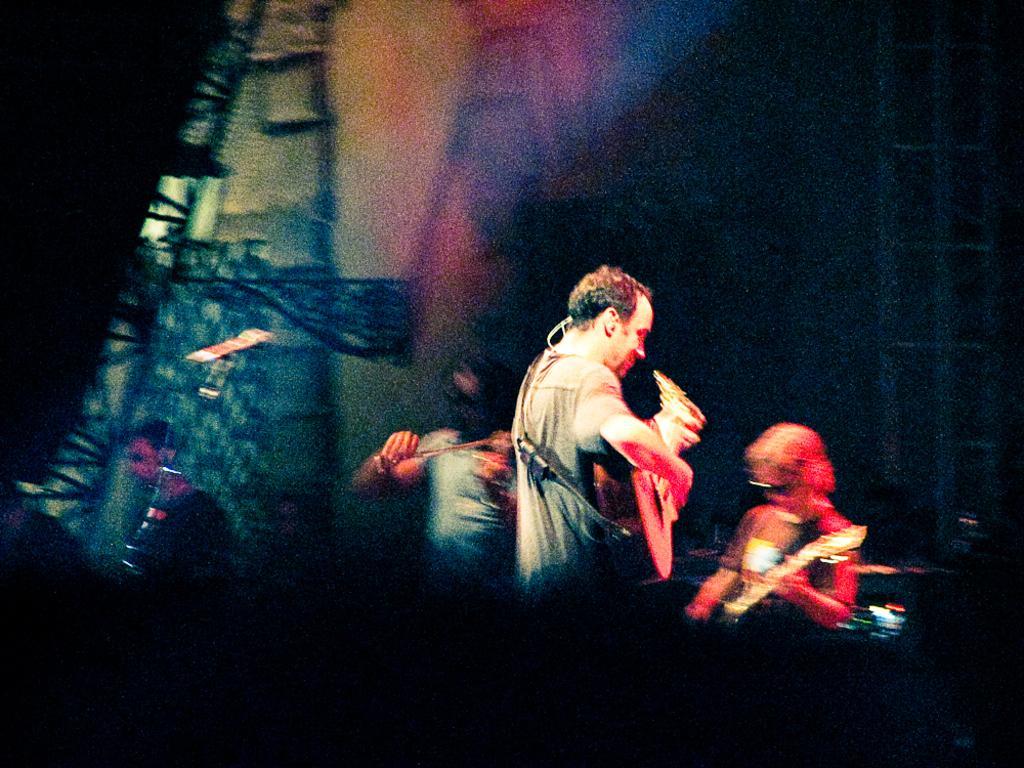Describe this image in one or two sentences. In this picture I can see the people holding musical instruments. 